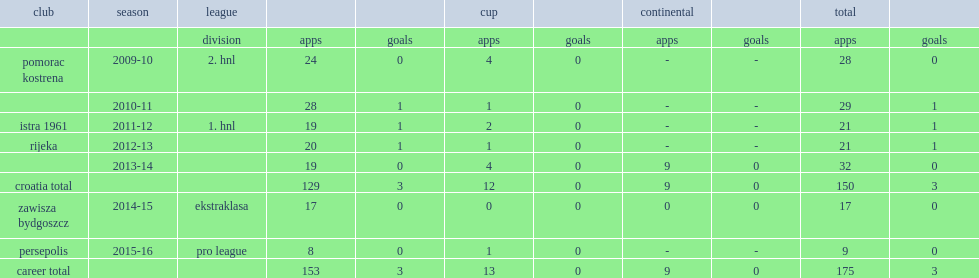Which club did maric play for in 2015-16? Persepolis. 